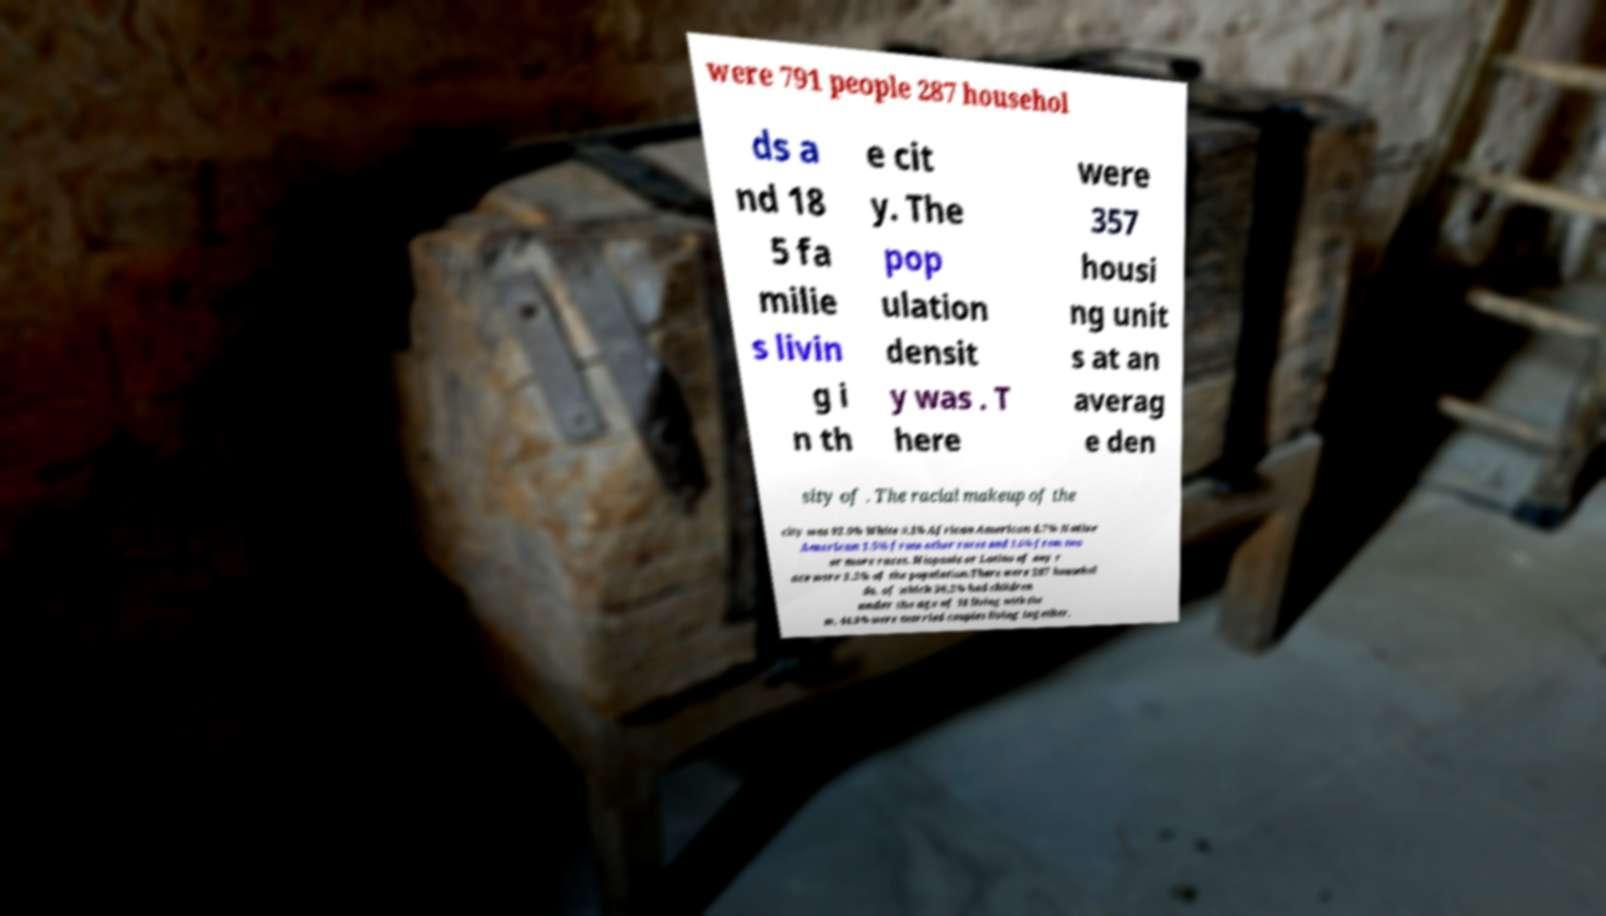Can you accurately transcribe the text from the provided image for me? were 791 people 287 househol ds a nd 18 5 fa milie s livin g i n th e cit y. The pop ulation densit y was . T here were 357 housi ng unit s at an averag e den sity of . The racial makeup of the city was 92.0% White 0.1% African American 4.7% Native American 1.5% from other races and 1.6% from two or more races. Hispanic or Latino of any r ace were 3.2% of the population.There were 287 househol ds, of which 36.2% had children under the age of 18 living with the m, 44.3% were married couples living together, 